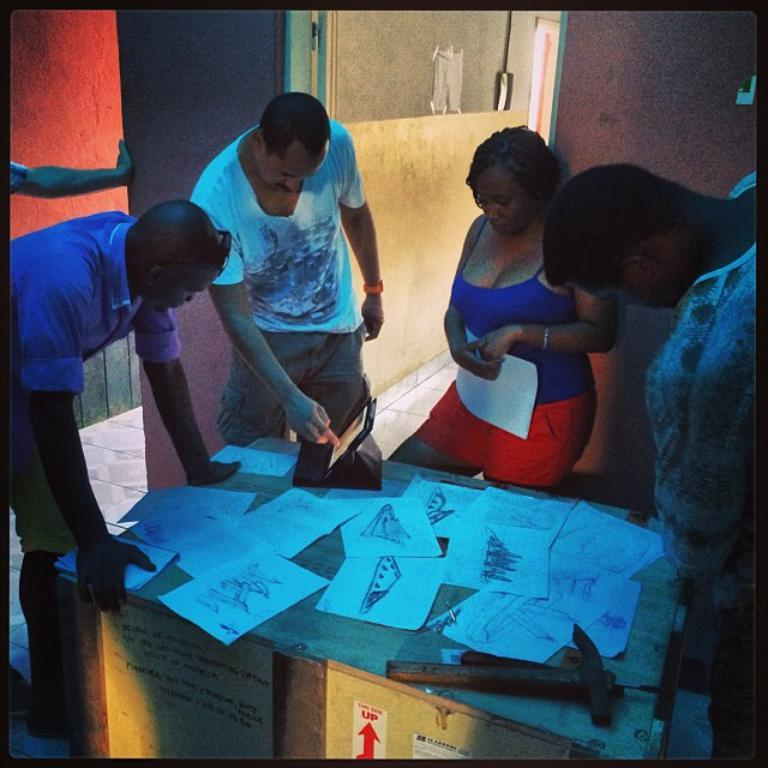What type of table is in the image? There is a wooden table in the image. What is on the wooden table? Papers, a hammer, and a device are on the wooden table. Are there any people near the wooden table? Yes, people are present around the wooden table. What is the woman holding in the image? The woman is holding a paper. What else can be seen with papers in the image? Papers are also on the wall. Is there a wrench being used to fix the device on the wooden table in the image? There is no wrench visible in the image, and it is not mentioned that the device is being fixed. Is it raining in the image? The image does not provide any information about the weather, so we cannot determine if it is raining or not. 